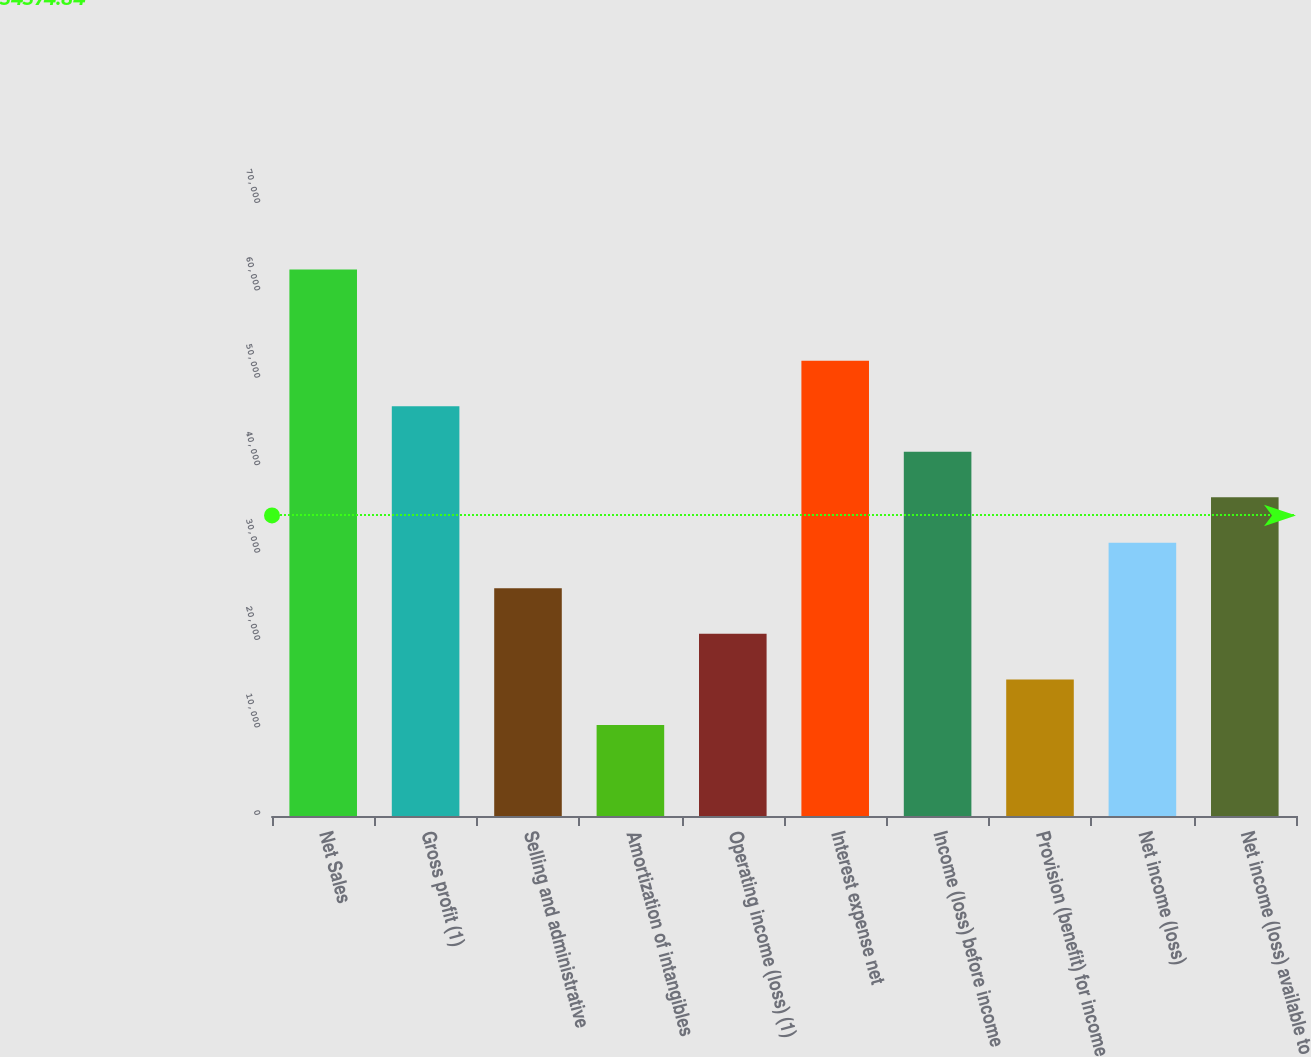<chart> <loc_0><loc_0><loc_500><loc_500><bar_chart><fcel>Net Sales<fcel>Gross profit (1)<fcel>Selling and administrative<fcel>Amortization of intangibles<fcel>Operating income (loss) (1)<fcel>Interest expense net<fcel>Income (loss) before income<fcel>Provision (benefit) for income<fcel>Net income (loss)<fcel>Net income (loss) available to<nl><fcel>62499.6<fcel>46874.7<fcel>26041.6<fcel>10416.7<fcel>20833.3<fcel>52083<fcel>41666.4<fcel>15625<fcel>31249.9<fcel>36458.2<nl></chart> 